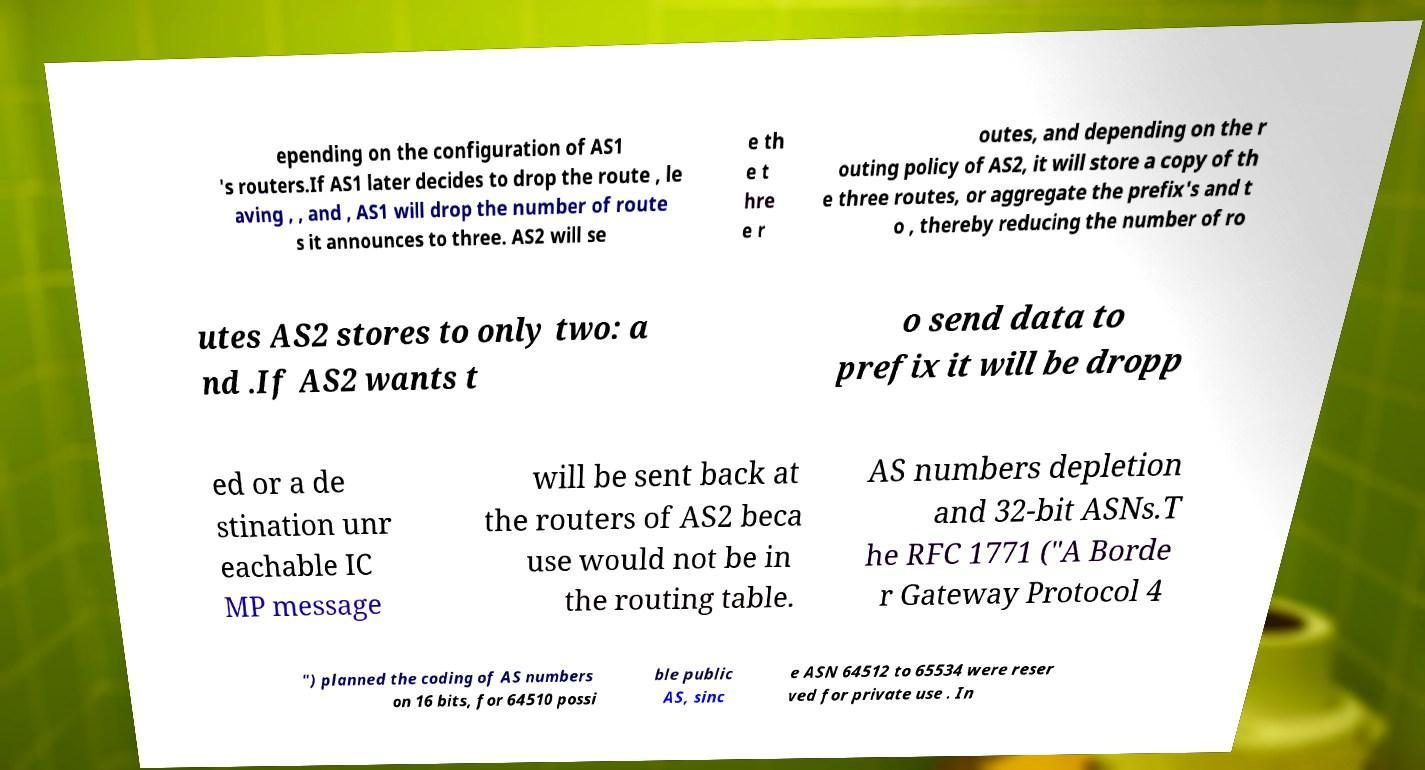There's text embedded in this image that I need extracted. Can you transcribe it verbatim? epending on the configuration of AS1 's routers.If AS1 later decides to drop the route , le aving , , and , AS1 will drop the number of route s it announces to three. AS2 will se e th e t hre e r outes, and depending on the r outing policy of AS2, it will store a copy of th e three routes, or aggregate the prefix's and t o , thereby reducing the number of ro utes AS2 stores to only two: a nd .If AS2 wants t o send data to prefix it will be dropp ed or a de stination unr eachable IC MP message will be sent back at the routers of AS2 beca use would not be in the routing table. AS numbers depletion and 32-bit ASNs.T he RFC 1771 ("A Borde r Gateway Protocol 4 ") planned the coding of AS numbers on 16 bits, for 64510 possi ble public AS, sinc e ASN 64512 to 65534 were reser ved for private use . In 